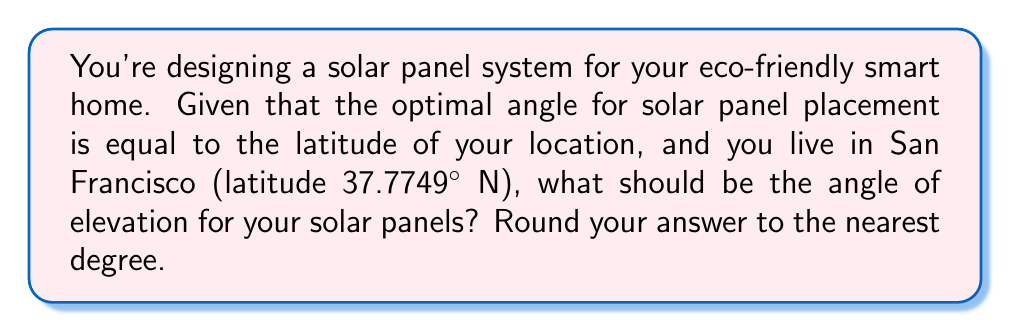Provide a solution to this math problem. To determine the optimal angle of elevation for solar panels, we follow these steps:

1. Understand the principle:
   The optimal angle for fixed solar panels is generally equal to the latitude of the location.

2. Identify the latitude:
   San Francisco's latitude is given as 37.7749° N.

3. Set up the equation:
   $\text{Optimal Angle} = \text{Latitude}$

4. Plug in the known value:
   $\text{Optimal Angle} = 37.7749°$

5. Round to the nearest degree:
   $37.7749°$ rounds to $38°$

Therefore, the optimal angle of elevation for the solar panels in San Francisco would be 38°.

[asy]
import geometry;

size(200);
draw((0,0)--(100,0), arrow=Arrow(TeXHead));
draw((0,0)--(0,100), arrow=Arrow(TeXHead));
draw((0,0)--(100,76), arrow=Arrow(TeXHead));

label("Ground", (50,-10));
label("Vertical", (-10,50));
label("Solar Panel", (70,50));

draw(arc((0,0),20,0,37.7749), arrow=Arrow(TeXHead));
label("38°", (15,10));
[/asy]
Answer: 38° 